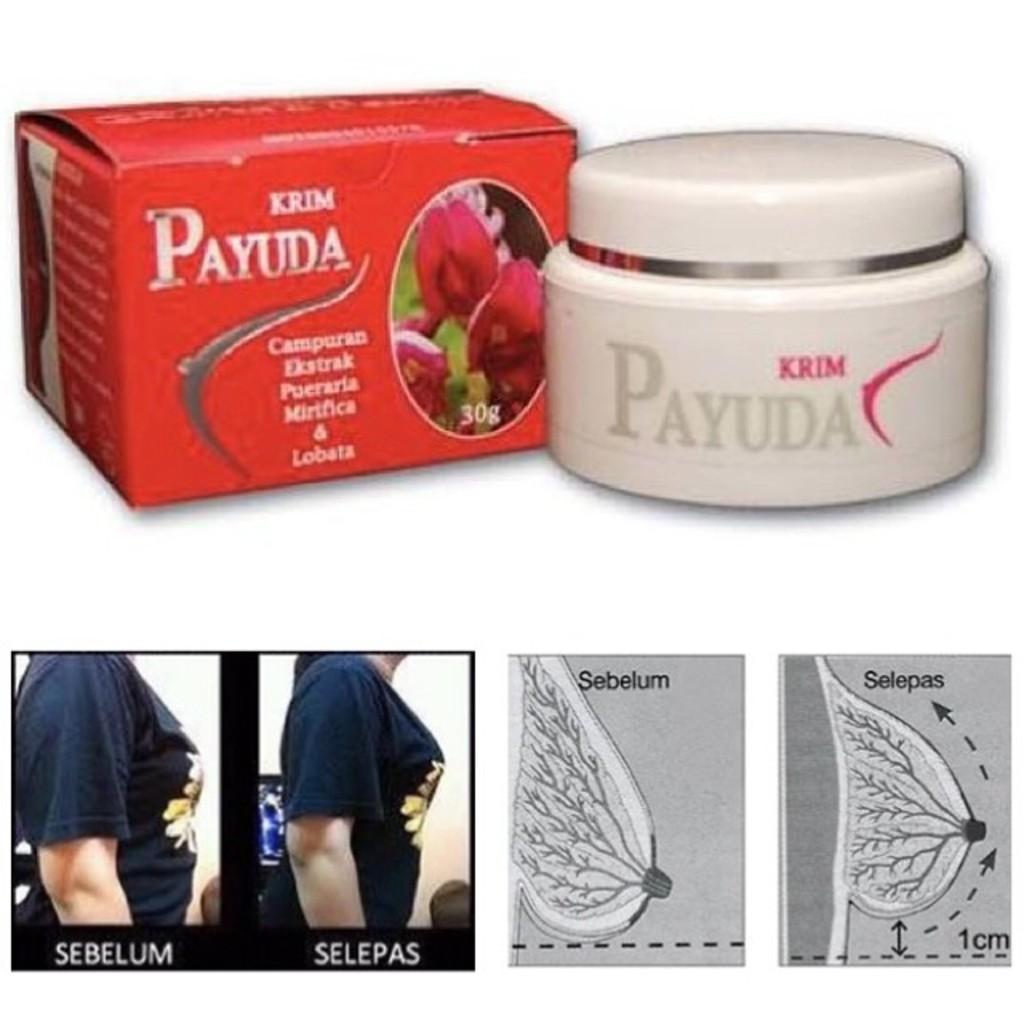How many centimeters can the payuda lift the breast?
Ensure brevity in your answer.  1. What is the first ingredient in the payuda?
Provide a short and direct response. Campuran. 